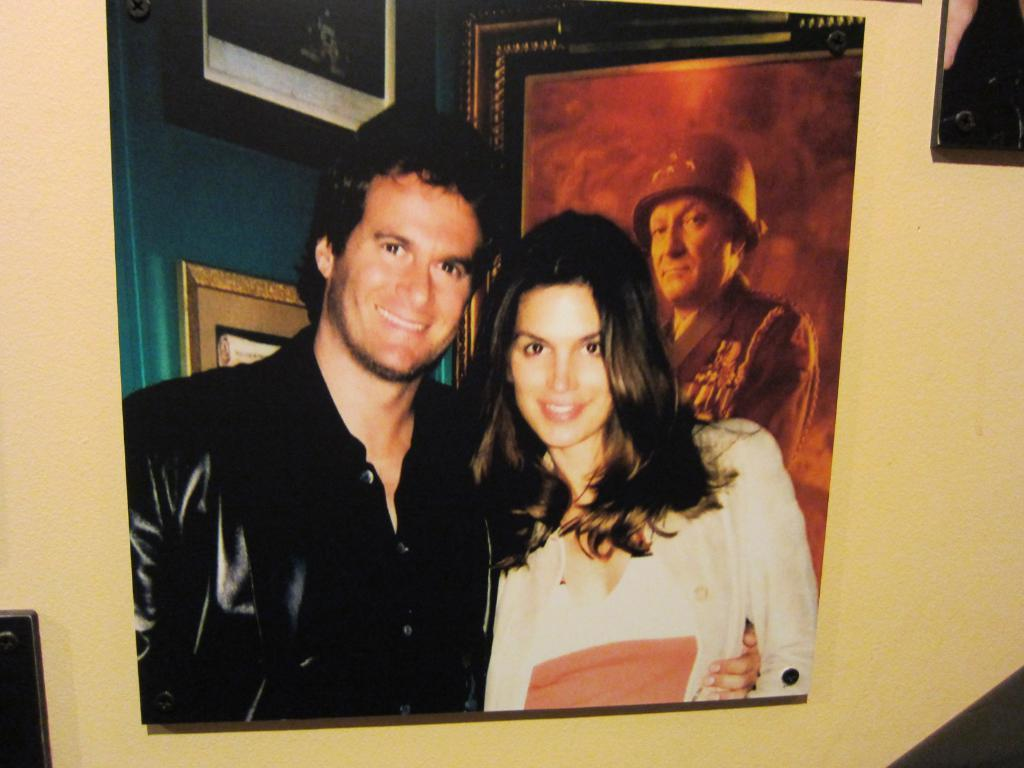What is hanging on the wall in the image? There is a photo frame on the wall in the image. What is depicted in the photo frame on the wall? The photo frame contains a picture of a man and a woman. Are there any other photo frames in the image? Yes, there is another photo frame in the image. What is shown in the second photo frame? The second photo frame contains a picture of a man. What is the man in the second photo frame wearing? The man in the second photo frame is wearing a cap. How many frogs can be seen jumping in the image? There are no frogs present in the image. What season is depicted in the image? The image does not depict a specific season; it only contains photo frames with pictures. 